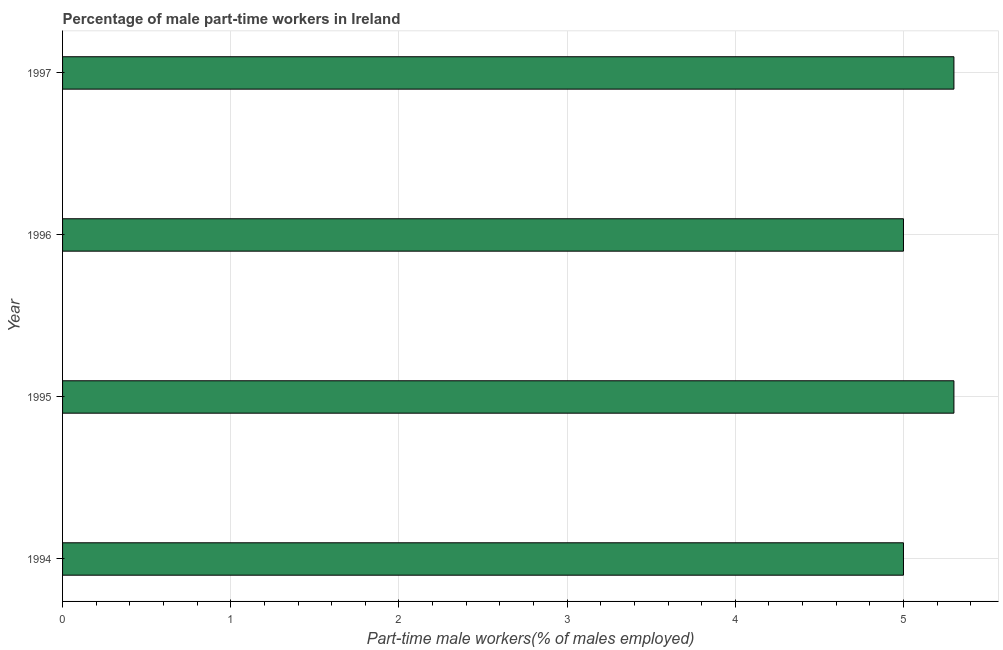What is the title of the graph?
Provide a succinct answer. Percentage of male part-time workers in Ireland. What is the label or title of the X-axis?
Your answer should be very brief. Part-time male workers(% of males employed). What is the label or title of the Y-axis?
Your response must be concise. Year. What is the percentage of part-time male workers in 1995?
Offer a very short reply. 5.3. Across all years, what is the maximum percentage of part-time male workers?
Keep it short and to the point. 5.3. Across all years, what is the minimum percentage of part-time male workers?
Provide a short and direct response. 5. In which year was the percentage of part-time male workers maximum?
Give a very brief answer. 1995. In which year was the percentage of part-time male workers minimum?
Your answer should be very brief. 1994. What is the sum of the percentage of part-time male workers?
Provide a succinct answer. 20.6. What is the average percentage of part-time male workers per year?
Your response must be concise. 5.15. What is the median percentage of part-time male workers?
Ensure brevity in your answer.  5.15. Do a majority of the years between 1995 and 1994 (inclusive) have percentage of part-time male workers greater than 1.2 %?
Your answer should be very brief. No. What is the ratio of the percentage of part-time male workers in 1995 to that in 1996?
Keep it short and to the point. 1.06. Is the difference between the percentage of part-time male workers in 1994 and 1997 greater than the difference between any two years?
Your response must be concise. Yes. What is the difference between the highest and the second highest percentage of part-time male workers?
Make the answer very short. 0. What is the difference between the highest and the lowest percentage of part-time male workers?
Keep it short and to the point. 0.3. Are all the bars in the graph horizontal?
Your answer should be compact. Yes. What is the difference between two consecutive major ticks on the X-axis?
Offer a very short reply. 1. What is the Part-time male workers(% of males employed) in 1995?
Keep it short and to the point. 5.3. What is the Part-time male workers(% of males employed) in 1996?
Provide a succinct answer. 5. What is the Part-time male workers(% of males employed) of 1997?
Provide a succinct answer. 5.3. What is the difference between the Part-time male workers(% of males employed) in 1994 and 1996?
Ensure brevity in your answer.  0. What is the ratio of the Part-time male workers(% of males employed) in 1994 to that in 1995?
Provide a short and direct response. 0.94. What is the ratio of the Part-time male workers(% of males employed) in 1994 to that in 1996?
Give a very brief answer. 1. What is the ratio of the Part-time male workers(% of males employed) in 1994 to that in 1997?
Provide a short and direct response. 0.94. What is the ratio of the Part-time male workers(% of males employed) in 1995 to that in 1996?
Provide a succinct answer. 1.06. What is the ratio of the Part-time male workers(% of males employed) in 1995 to that in 1997?
Offer a very short reply. 1. What is the ratio of the Part-time male workers(% of males employed) in 1996 to that in 1997?
Ensure brevity in your answer.  0.94. 